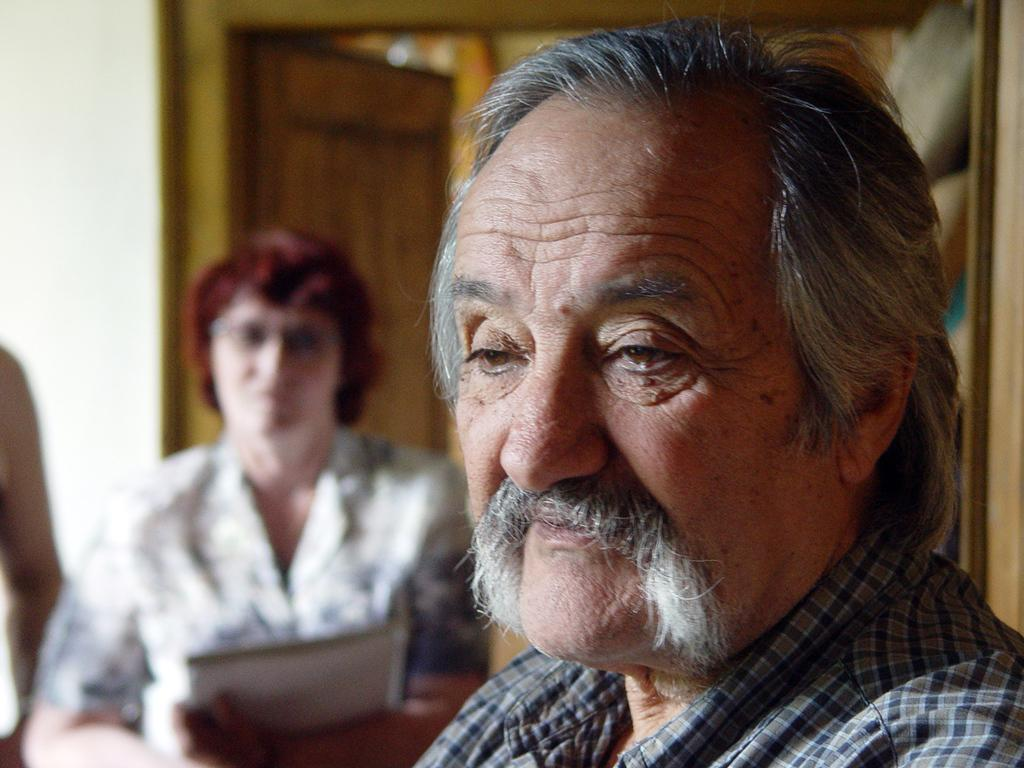How many people are in the image? There are persons in the image, but the exact number is not specified. What are the persons wearing? The persons are wearing clothes. Can you describe the background of the image? The background of the image is blurred. What type of unit can be seen in the image? There is no unit present in the image. What place is depicted in the image? The image does not depict a specific place; it only shows persons wearing clothes with a blurred background. 